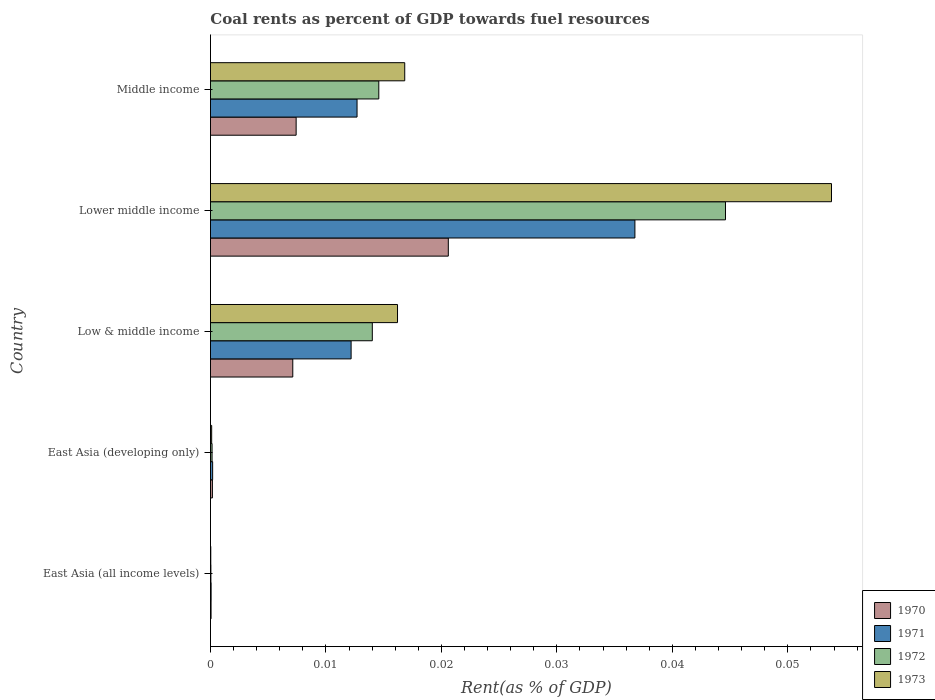How many different coloured bars are there?
Offer a terse response. 4. How many bars are there on the 3rd tick from the top?
Your answer should be compact. 4. How many bars are there on the 2nd tick from the bottom?
Give a very brief answer. 4. What is the label of the 2nd group of bars from the top?
Your answer should be very brief. Lower middle income. What is the coal rent in 1970 in Low & middle income?
Offer a very short reply. 0.01. Across all countries, what is the maximum coal rent in 1973?
Offer a terse response. 0.05. Across all countries, what is the minimum coal rent in 1973?
Make the answer very short. 2.64171247686014e-5. In which country was the coal rent in 1972 maximum?
Your answer should be very brief. Lower middle income. In which country was the coal rent in 1971 minimum?
Your answer should be very brief. East Asia (all income levels). What is the total coal rent in 1972 in the graph?
Offer a terse response. 0.07. What is the difference between the coal rent in 1971 in East Asia (all income levels) and that in Low & middle income?
Give a very brief answer. -0.01. What is the difference between the coal rent in 1971 in East Asia (developing only) and the coal rent in 1973 in Low & middle income?
Provide a short and direct response. -0.02. What is the average coal rent in 1971 per country?
Offer a very short reply. 0.01. What is the difference between the coal rent in 1971 and coal rent in 1972 in East Asia (developing only)?
Make the answer very short. 4.9569085611083014e-5. In how many countries, is the coal rent in 1971 greater than 0.05 %?
Provide a short and direct response. 0. What is the ratio of the coal rent in 1973 in East Asia (developing only) to that in Low & middle income?
Your answer should be very brief. 0.01. What is the difference between the highest and the second highest coal rent in 1971?
Make the answer very short. 0.02. What is the difference between the highest and the lowest coal rent in 1972?
Your answer should be very brief. 0.04. What does the 2nd bar from the top in Lower middle income represents?
Offer a very short reply. 1972. What does the 2nd bar from the bottom in Low & middle income represents?
Keep it short and to the point. 1971. How many bars are there?
Your answer should be compact. 20. What is the difference between two consecutive major ticks on the X-axis?
Keep it short and to the point. 0.01. Are the values on the major ticks of X-axis written in scientific E-notation?
Make the answer very short. No. Where does the legend appear in the graph?
Your answer should be compact. Bottom right. What is the title of the graph?
Make the answer very short. Coal rents as percent of GDP towards fuel resources. Does "1977" appear as one of the legend labels in the graph?
Provide a succinct answer. No. What is the label or title of the X-axis?
Offer a terse response. Rent(as % of GDP). What is the Rent(as % of GDP) of 1970 in East Asia (all income levels)?
Give a very brief answer. 5.1314079013758e-5. What is the Rent(as % of GDP) of 1971 in East Asia (all income levels)?
Give a very brief answer. 5.470114168356261e-5. What is the Rent(as % of GDP) in 1972 in East Asia (all income levels)?
Keep it short and to the point. 3.67730514806032e-5. What is the Rent(as % of GDP) in 1973 in East Asia (all income levels)?
Your answer should be compact. 2.64171247686014e-5. What is the Rent(as % of GDP) in 1970 in East Asia (developing only)?
Provide a short and direct response. 0. What is the Rent(as % of GDP) of 1971 in East Asia (developing only)?
Keep it short and to the point. 0. What is the Rent(as % of GDP) of 1972 in East Asia (developing only)?
Your answer should be compact. 0. What is the Rent(as % of GDP) in 1973 in East Asia (developing only)?
Offer a terse response. 0. What is the Rent(as % of GDP) of 1970 in Low & middle income?
Your answer should be compact. 0.01. What is the Rent(as % of GDP) of 1971 in Low & middle income?
Provide a short and direct response. 0.01. What is the Rent(as % of GDP) of 1972 in Low & middle income?
Provide a short and direct response. 0.01. What is the Rent(as % of GDP) in 1973 in Low & middle income?
Give a very brief answer. 0.02. What is the Rent(as % of GDP) in 1970 in Lower middle income?
Ensure brevity in your answer.  0.02. What is the Rent(as % of GDP) in 1971 in Lower middle income?
Ensure brevity in your answer.  0.04. What is the Rent(as % of GDP) in 1972 in Lower middle income?
Give a very brief answer. 0.04. What is the Rent(as % of GDP) of 1973 in Lower middle income?
Keep it short and to the point. 0.05. What is the Rent(as % of GDP) in 1970 in Middle income?
Make the answer very short. 0.01. What is the Rent(as % of GDP) of 1971 in Middle income?
Ensure brevity in your answer.  0.01. What is the Rent(as % of GDP) of 1972 in Middle income?
Your response must be concise. 0.01. What is the Rent(as % of GDP) in 1973 in Middle income?
Make the answer very short. 0.02. Across all countries, what is the maximum Rent(as % of GDP) in 1970?
Give a very brief answer. 0.02. Across all countries, what is the maximum Rent(as % of GDP) in 1971?
Provide a short and direct response. 0.04. Across all countries, what is the maximum Rent(as % of GDP) in 1972?
Give a very brief answer. 0.04. Across all countries, what is the maximum Rent(as % of GDP) in 1973?
Provide a succinct answer. 0.05. Across all countries, what is the minimum Rent(as % of GDP) of 1970?
Provide a short and direct response. 5.1314079013758e-5. Across all countries, what is the minimum Rent(as % of GDP) in 1971?
Provide a succinct answer. 5.470114168356261e-5. Across all countries, what is the minimum Rent(as % of GDP) in 1972?
Provide a succinct answer. 3.67730514806032e-5. Across all countries, what is the minimum Rent(as % of GDP) of 1973?
Provide a succinct answer. 2.64171247686014e-5. What is the total Rent(as % of GDP) of 1970 in the graph?
Your answer should be very brief. 0.04. What is the total Rent(as % of GDP) in 1971 in the graph?
Offer a very short reply. 0.06. What is the total Rent(as % of GDP) of 1972 in the graph?
Your response must be concise. 0.07. What is the total Rent(as % of GDP) in 1973 in the graph?
Your answer should be compact. 0.09. What is the difference between the Rent(as % of GDP) of 1970 in East Asia (all income levels) and that in East Asia (developing only)?
Ensure brevity in your answer.  -0. What is the difference between the Rent(as % of GDP) of 1971 in East Asia (all income levels) and that in East Asia (developing only)?
Your response must be concise. -0. What is the difference between the Rent(as % of GDP) of 1972 in East Asia (all income levels) and that in East Asia (developing only)?
Your answer should be very brief. -0. What is the difference between the Rent(as % of GDP) in 1973 in East Asia (all income levels) and that in East Asia (developing only)?
Your answer should be compact. -0. What is the difference between the Rent(as % of GDP) of 1970 in East Asia (all income levels) and that in Low & middle income?
Your answer should be compact. -0.01. What is the difference between the Rent(as % of GDP) of 1971 in East Asia (all income levels) and that in Low & middle income?
Provide a short and direct response. -0.01. What is the difference between the Rent(as % of GDP) of 1972 in East Asia (all income levels) and that in Low & middle income?
Make the answer very short. -0.01. What is the difference between the Rent(as % of GDP) in 1973 in East Asia (all income levels) and that in Low & middle income?
Your response must be concise. -0.02. What is the difference between the Rent(as % of GDP) of 1970 in East Asia (all income levels) and that in Lower middle income?
Make the answer very short. -0.02. What is the difference between the Rent(as % of GDP) of 1971 in East Asia (all income levels) and that in Lower middle income?
Your response must be concise. -0.04. What is the difference between the Rent(as % of GDP) in 1972 in East Asia (all income levels) and that in Lower middle income?
Give a very brief answer. -0.04. What is the difference between the Rent(as % of GDP) in 1973 in East Asia (all income levels) and that in Lower middle income?
Your answer should be compact. -0.05. What is the difference between the Rent(as % of GDP) in 1970 in East Asia (all income levels) and that in Middle income?
Your response must be concise. -0.01. What is the difference between the Rent(as % of GDP) of 1971 in East Asia (all income levels) and that in Middle income?
Your answer should be very brief. -0.01. What is the difference between the Rent(as % of GDP) in 1972 in East Asia (all income levels) and that in Middle income?
Make the answer very short. -0.01. What is the difference between the Rent(as % of GDP) of 1973 in East Asia (all income levels) and that in Middle income?
Offer a terse response. -0.02. What is the difference between the Rent(as % of GDP) in 1970 in East Asia (developing only) and that in Low & middle income?
Ensure brevity in your answer.  -0.01. What is the difference between the Rent(as % of GDP) of 1971 in East Asia (developing only) and that in Low & middle income?
Make the answer very short. -0.01. What is the difference between the Rent(as % of GDP) of 1972 in East Asia (developing only) and that in Low & middle income?
Ensure brevity in your answer.  -0.01. What is the difference between the Rent(as % of GDP) in 1973 in East Asia (developing only) and that in Low & middle income?
Your response must be concise. -0.02. What is the difference between the Rent(as % of GDP) in 1970 in East Asia (developing only) and that in Lower middle income?
Your answer should be compact. -0.02. What is the difference between the Rent(as % of GDP) in 1971 in East Asia (developing only) and that in Lower middle income?
Offer a terse response. -0.04. What is the difference between the Rent(as % of GDP) of 1972 in East Asia (developing only) and that in Lower middle income?
Your response must be concise. -0.04. What is the difference between the Rent(as % of GDP) in 1973 in East Asia (developing only) and that in Lower middle income?
Your response must be concise. -0.05. What is the difference between the Rent(as % of GDP) in 1970 in East Asia (developing only) and that in Middle income?
Give a very brief answer. -0.01. What is the difference between the Rent(as % of GDP) in 1971 in East Asia (developing only) and that in Middle income?
Your answer should be compact. -0.01. What is the difference between the Rent(as % of GDP) in 1972 in East Asia (developing only) and that in Middle income?
Give a very brief answer. -0.01. What is the difference between the Rent(as % of GDP) of 1973 in East Asia (developing only) and that in Middle income?
Offer a terse response. -0.02. What is the difference between the Rent(as % of GDP) in 1970 in Low & middle income and that in Lower middle income?
Make the answer very short. -0.01. What is the difference between the Rent(as % of GDP) of 1971 in Low & middle income and that in Lower middle income?
Your response must be concise. -0.02. What is the difference between the Rent(as % of GDP) of 1972 in Low & middle income and that in Lower middle income?
Make the answer very short. -0.03. What is the difference between the Rent(as % of GDP) in 1973 in Low & middle income and that in Lower middle income?
Offer a terse response. -0.04. What is the difference between the Rent(as % of GDP) of 1970 in Low & middle income and that in Middle income?
Provide a short and direct response. -0. What is the difference between the Rent(as % of GDP) in 1971 in Low & middle income and that in Middle income?
Your answer should be very brief. -0. What is the difference between the Rent(as % of GDP) of 1972 in Low & middle income and that in Middle income?
Your answer should be very brief. -0. What is the difference between the Rent(as % of GDP) in 1973 in Low & middle income and that in Middle income?
Keep it short and to the point. -0. What is the difference between the Rent(as % of GDP) in 1970 in Lower middle income and that in Middle income?
Offer a very short reply. 0.01. What is the difference between the Rent(as % of GDP) in 1971 in Lower middle income and that in Middle income?
Make the answer very short. 0.02. What is the difference between the Rent(as % of GDP) of 1973 in Lower middle income and that in Middle income?
Your answer should be very brief. 0.04. What is the difference between the Rent(as % of GDP) of 1970 in East Asia (all income levels) and the Rent(as % of GDP) of 1971 in East Asia (developing only)?
Offer a terse response. -0. What is the difference between the Rent(as % of GDP) in 1970 in East Asia (all income levels) and the Rent(as % of GDP) in 1972 in East Asia (developing only)?
Your answer should be very brief. -0. What is the difference between the Rent(as % of GDP) in 1970 in East Asia (all income levels) and the Rent(as % of GDP) in 1973 in East Asia (developing only)?
Your answer should be compact. -0. What is the difference between the Rent(as % of GDP) of 1971 in East Asia (all income levels) and the Rent(as % of GDP) of 1972 in East Asia (developing only)?
Your answer should be compact. -0. What is the difference between the Rent(as % of GDP) in 1972 in East Asia (all income levels) and the Rent(as % of GDP) in 1973 in East Asia (developing only)?
Keep it short and to the point. -0. What is the difference between the Rent(as % of GDP) of 1970 in East Asia (all income levels) and the Rent(as % of GDP) of 1971 in Low & middle income?
Your response must be concise. -0.01. What is the difference between the Rent(as % of GDP) of 1970 in East Asia (all income levels) and the Rent(as % of GDP) of 1972 in Low & middle income?
Give a very brief answer. -0.01. What is the difference between the Rent(as % of GDP) of 1970 in East Asia (all income levels) and the Rent(as % of GDP) of 1973 in Low & middle income?
Give a very brief answer. -0.02. What is the difference between the Rent(as % of GDP) in 1971 in East Asia (all income levels) and the Rent(as % of GDP) in 1972 in Low & middle income?
Offer a very short reply. -0.01. What is the difference between the Rent(as % of GDP) of 1971 in East Asia (all income levels) and the Rent(as % of GDP) of 1973 in Low & middle income?
Ensure brevity in your answer.  -0.02. What is the difference between the Rent(as % of GDP) in 1972 in East Asia (all income levels) and the Rent(as % of GDP) in 1973 in Low & middle income?
Make the answer very short. -0.02. What is the difference between the Rent(as % of GDP) of 1970 in East Asia (all income levels) and the Rent(as % of GDP) of 1971 in Lower middle income?
Your response must be concise. -0.04. What is the difference between the Rent(as % of GDP) of 1970 in East Asia (all income levels) and the Rent(as % of GDP) of 1972 in Lower middle income?
Provide a short and direct response. -0.04. What is the difference between the Rent(as % of GDP) in 1970 in East Asia (all income levels) and the Rent(as % of GDP) in 1973 in Lower middle income?
Your answer should be compact. -0.05. What is the difference between the Rent(as % of GDP) of 1971 in East Asia (all income levels) and the Rent(as % of GDP) of 1972 in Lower middle income?
Your response must be concise. -0.04. What is the difference between the Rent(as % of GDP) in 1971 in East Asia (all income levels) and the Rent(as % of GDP) in 1973 in Lower middle income?
Make the answer very short. -0.05. What is the difference between the Rent(as % of GDP) in 1972 in East Asia (all income levels) and the Rent(as % of GDP) in 1973 in Lower middle income?
Offer a terse response. -0.05. What is the difference between the Rent(as % of GDP) in 1970 in East Asia (all income levels) and the Rent(as % of GDP) in 1971 in Middle income?
Offer a very short reply. -0.01. What is the difference between the Rent(as % of GDP) of 1970 in East Asia (all income levels) and the Rent(as % of GDP) of 1972 in Middle income?
Offer a terse response. -0.01. What is the difference between the Rent(as % of GDP) in 1970 in East Asia (all income levels) and the Rent(as % of GDP) in 1973 in Middle income?
Ensure brevity in your answer.  -0.02. What is the difference between the Rent(as % of GDP) in 1971 in East Asia (all income levels) and the Rent(as % of GDP) in 1972 in Middle income?
Offer a terse response. -0.01. What is the difference between the Rent(as % of GDP) in 1971 in East Asia (all income levels) and the Rent(as % of GDP) in 1973 in Middle income?
Provide a succinct answer. -0.02. What is the difference between the Rent(as % of GDP) in 1972 in East Asia (all income levels) and the Rent(as % of GDP) in 1973 in Middle income?
Your answer should be compact. -0.02. What is the difference between the Rent(as % of GDP) in 1970 in East Asia (developing only) and the Rent(as % of GDP) in 1971 in Low & middle income?
Ensure brevity in your answer.  -0.01. What is the difference between the Rent(as % of GDP) in 1970 in East Asia (developing only) and the Rent(as % of GDP) in 1972 in Low & middle income?
Offer a very short reply. -0.01. What is the difference between the Rent(as % of GDP) in 1970 in East Asia (developing only) and the Rent(as % of GDP) in 1973 in Low & middle income?
Your answer should be very brief. -0.02. What is the difference between the Rent(as % of GDP) in 1971 in East Asia (developing only) and the Rent(as % of GDP) in 1972 in Low & middle income?
Provide a succinct answer. -0.01. What is the difference between the Rent(as % of GDP) of 1971 in East Asia (developing only) and the Rent(as % of GDP) of 1973 in Low & middle income?
Offer a terse response. -0.02. What is the difference between the Rent(as % of GDP) of 1972 in East Asia (developing only) and the Rent(as % of GDP) of 1973 in Low & middle income?
Give a very brief answer. -0.02. What is the difference between the Rent(as % of GDP) in 1970 in East Asia (developing only) and the Rent(as % of GDP) in 1971 in Lower middle income?
Make the answer very short. -0.04. What is the difference between the Rent(as % of GDP) in 1970 in East Asia (developing only) and the Rent(as % of GDP) in 1972 in Lower middle income?
Ensure brevity in your answer.  -0.04. What is the difference between the Rent(as % of GDP) of 1970 in East Asia (developing only) and the Rent(as % of GDP) of 1973 in Lower middle income?
Offer a terse response. -0.05. What is the difference between the Rent(as % of GDP) of 1971 in East Asia (developing only) and the Rent(as % of GDP) of 1972 in Lower middle income?
Keep it short and to the point. -0.04. What is the difference between the Rent(as % of GDP) in 1971 in East Asia (developing only) and the Rent(as % of GDP) in 1973 in Lower middle income?
Offer a very short reply. -0.05. What is the difference between the Rent(as % of GDP) in 1972 in East Asia (developing only) and the Rent(as % of GDP) in 1973 in Lower middle income?
Give a very brief answer. -0.05. What is the difference between the Rent(as % of GDP) of 1970 in East Asia (developing only) and the Rent(as % of GDP) of 1971 in Middle income?
Your answer should be very brief. -0.01. What is the difference between the Rent(as % of GDP) of 1970 in East Asia (developing only) and the Rent(as % of GDP) of 1972 in Middle income?
Provide a succinct answer. -0.01. What is the difference between the Rent(as % of GDP) of 1970 in East Asia (developing only) and the Rent(as % of GDP) of 1973 in Middle income?
Provide a short and direct response. -0.02. What is the difference between the Rent(as % of GDP) in 1971 in East Asia (developing only) and the Rent(as % of GDP) in 1972 in Middle income?
Your answer should be very brief. -0.01. What is the difference between the Rent(as % of GDP) in 1971 in East Asia (developing only) and the Rent(as % of GDP) in 1973 in Middle income?
Offer a very short reply. -0.02. What is the difference between the Rent(as % of GDP) in 1972 in East Asia (developing only) and the Rent(as % of GDP) in 1973 in Middle income?
Your answer should be very brief. -0.02. What is the difference between the Rent(as % of GDP) of 1970 in Low & middle income and the Rent(as % of GDP) of 1971 in Lower middle income?
Offer a terse response. -0.03. What is the difference between the Rent(as % of GDP) of 1970 in Low & middle income and the Rent(as % of GDP) of 1972 in Lower middle income?
Provide a succinct answer. -0.04. What is the difference between the Rent(as % of GDP) of 1970 in Low & middle income and the Rent(as % of GDP) of 1973 in Lower middle income?
Offer a terse response. -0.05. What is the difference between the Rent(as % of GDP) in 1971 in Low & middle income and the Rent(as % of GDP) in 1972 in Lower middle income?
Your answer should be compact. -0.03. What is the difference between the Rent(as % of GDP) in 1971 in Low & middle income and the Rent(as % of GDP) in 1973 in Lower middle income?
Keep it short and to the point. -0.04. What is the difference between the Rent(as % of GDP) of 1972 in Low & middle income and the Rent(as % of GDP) of 1973 in Lower middle income?
Your answer should be compact. -0.04. What is the difference between the Rent(as % of GDP) of 1970 in Low & middle income and the Rent(as % of GDP) of 1971 in Middle income?
Give a very brief answer. -0.01. What is the difference between the Rent(as % of GDP) in 1970 in Low & middle income and the Rent(as % of GDP) in 1972 in Middle income?
Your answer should be very brief. -0.01. What is the difference between the Rent(as % of GDP) in 1970 in Low & middle income and the Rent(as % of GDP) in 1973 in Middle income?
Ensure brevity in your answer.  -0.01. What is the difference between the Rent(as % of GDP) in 1971 in Low & middle income and the Rent(as % of GDP) in 1972 in Middle income?
Give a very brief answer. -0. What is the difference between the Rent(as % of GDP) in 1971 in Low & middle income and the Rent(as % of GDP) in 1973 in Middle income?
Your answer should be very brief. -0. What is the difference between the Rent(as % of GDP) in 1972 in Low & middle income and the Rent(as % of GDP) in 1973 in Middle income?
Give a very brief answer. -0. What is the difference between the Rent(as % of GDP) in 1970 in Lower middle income and the Rent(as % of GDP) in 1971 in Middle income?
Your answer should be compact. 0.01. What is the difference between the Rent(as % of GDP) in 1970 in Lower middle income and the Rent(as % of GDP) in 1972 in Middle income?
Provide a succinct answer. 0.01. What is the difference between the Rent(as % of GDP) of 1970 in Lower middle income and the Rent(as % of GDP) of 1973 in Middle income?
Offer a very short reply. 0. What is the difference between the Rent(as % of GDP) in 1971 in Lower middle income and the Rent(as % of GDP) in 1972 in Middle income?
Provide a short and direct response. 0.02. What is the difference between the Rent(as % of GDP) in 1971 in Lower middle income and the Rent(as % of GDP) in 1973 in Middle income?
Give a very brief answer. 0.02. What is the difference between the Rent(as % of GDP) in 1972 in Lower middle income and the Rent(as % of GDP) in 1973 in Middle income?
Your answer should be very brief. 0.03. What is the average Rent(as % of GDP) of 1970 per country?
Your answer should be very brief. 0.01. What is the average Rent(as % of GDP) of 1971 per country?
Your answer should be compact. 0.01. What is the average Rent(as % of GDP) of 1972 per country?
Make the answer very short. 0.01. What is the average Rent(as % of GDP) of 1973 per country?
Your answer should be very brief. 0.02. What is the difference between the Rent(as % of GDP) of 1970 and Rent(as % of GDP) of 1971 in East Asia (all income levels)?
Provide a short and direct response. -0. What is the difference between the Rent(as % of GDP) of 1970 and Rent(as % of GDP) of 1972 in East Asia (all income levels)?
Ensure brevity in your answer.  0. What is the difference between the Rent(as % of GDP) of 1970 and Rent(as % of GDP) of 1973 in East Asia (all income levels)?
Your answer should be compact. 0. What is the difference between the Rent(as % of GDP) in 1971 and Rent(as % of GDP) in 1972 in East Asia (all income levels)?
Offer a terse response. 0. What is the difference between the Rent(as % of GDP) in 1971 and Rent(as % of GDP) in 1973 in East Asia (all income levels)?
Provide a succinct answer. 0. What is the difference between the Rent(as % of GDP) in 1972 and Rent(as % of GDP) in 1973 in East Asia (all income levels)?
Provide a short and direct response. 0. What is the difference between the Rent(as % of GDP) in 1971 and Rent(as % of GDP) in 1972 in East Asia (developing only)?
Offer a very short reply. 0. What is the difference between the Rent(as % of GDP) in 1972 and Rent(as % of GDP) in 1973 in East Asia (developing only)?
Give a very brief answer. 0. What is the difference between the Rent(as % of GDP) of 1970 and Rent(as % of GDP) of 1971 in Low & middle income?
Provide a succinct answer. -0.01. What is the difference between the Rent(as % of GDP) in 1970 and Rent(as % of GDP) in 1972 in Low & middle income?
Offer a terse response. -0.01. What is the difference between the Rent(as % of GDP) of 1970 and Rent(as % of GDP) of 1973 in Low & middle income?
Provide a succinct answer. -0.01. What is the difference between the Rent(as % of GDP) of 1971 and Rent(as % of GDP) of 1972 in Low & middle income?
Provide a succinct answer. -0. What is the difference between the Rent(as % of GDP) in 1971 and Rent(as % of GDP) in 1973 in Low & middle income?
Ensure brevity in your answer.  -0. What is the difference between the Rent(as % of GDP) of 1972 and Rent(as % of GDP) of 1973 in Low & middle income?
Keep it short and to the point. -0. What is the difference between the Rent(as % of GDP) in 1970 and Rent(as % of GDP) in 1971 in Lower middle income?
Your answer should be very brief. -0.02. What is the difference between the Rent(as % of GDP) of 1970 and Rent(as % of GDP) of 1972 in Lower middle income?
Your answer should be compact. -0.02. What is the difference between the Rent(as % of GDP) of 1970 and Rent(as % of GDP) of 1973 in Lower middle income?
Give a very brief answer. -0.03. What is the difference between the Rent(as % of GDP) in 1971 and Rent(as % of GDP) in 1972 in Lower middle income?
Your response must be concise. -0.01. What is the difference between the Rent(as % of GDP) in 1971 and Rent(as % of GDP) in 1973 in Lower middle income?
Give a very brief answer. -0.02. What is the difference between the Rent(as % of GDP) in 1972 and Rent(as % of GDP) in 1973 in Lower middle income?
Ensure brevity in your answer.  -0.01. What is the difference between the Rent(as % of GDP) in 1970 and Rent(as % of GDP) in 1971 in Middle income?
Your response must be concise. -0.01. What is the difference between the Rent(as % of GDP) in 1970 and Rent(as % of GDP) in 1972 in Middle income?
Make the answer very short. -0.01. What is the difference between the Rent(as % of GDP) of 1970 and Rent(as % of GDP) of 1973 in Middle income?
Provide a succinct answer. -0.01. What is the difference between the Rent(as % of GDP) in 1971 and Rent(as % of GDP) in 1972 in Middle income?
Provide a short and direct response. -0. What is the difference between the Rent(as % of GDP) in 1971 and Rent(as % of GDP) in 1973 in Middle income?
Provide a succinct answer. -0. What is the difference between the Rent(as % of GDP) of 1972 and Rent(as % of GDP) of 1973 in Middle income?
Make the answer very short. -0. What is the ratio of the Rent(as % of GDP) in 1970 in East Asia (all income levels) to that in East Asia (developing only)?
Your answer should be compact. 0.31. What is the ratio of the Rent(as % of GDP) of 1971 in East Asia (all income levels) to that in East Asia (developing only)?
Your answer should be compact. 0.29. What is the ratio of the Rent(as % of GDP) in 1972 in East Asia (all income levels) to that in East Asia (developing only)?
Offer a terse response. 0.27. What is the ratio of the Rent(as % of GDP) in 1973 in East Asia (all income levels) to that in East Asia (developing only)?
Provide a succinct answer. 0.26. What is the ratio of the Rent(as % of GDP) in 1970 in East Asia (all income levels) to that in Low & middle income?
Provide a succinct answer. 0.01. What is the ratio of the Rent(as % of GDP) of 1971 in East Asia (all income levels) to that in Low & middle income?
Provide a succinct answer. 0. What is the ratio of the Rent(as % of GDP) of 1972 in East Asia (all income levels) to that in Low & middle income?
Offer a very short reply. 0. What is the ratio of the Rent(as % of GDP) in 1973 in East Asia (all income levels) to that in Low & middle income?
Make the answer very short. 0. What is the ratio of the Rent(as % of GDP) in 1970 in East Asia (all income levels) to that in Lower middle income?
Your response must be concise. 0. What is the ratio of the Rent(as % of GDP) of 1971 in East Asia (all income levels) to that in Lower middle income?
Keep it short and to the point. 0. What is the ratio of the Rent(as % of GDP) of 1972 in East Asia (all income levels) to that in Lower middle income?
Give a very brief answer. 0. What is the ratio of the Rent(as % of GDP) of 1970 in East Asia (all income levels) to that in Middle income?
Offer a terse response. 0.01. What is the ratio of the Rent(as % of GDP) in 1971 in East Asia (all income levels) to that in Middle income?
Ensure brevity in your answer.  0. What is the ratio of the Rent(as % of GDP) in 1972 in East Asia (all income levels) to that in Middle income?
Provide a short and direct response. 0. What is the ratio of the Rent(as % of GDP) of 1973 in East Asia (all income levels) to that in Middle income?
Your answer should be very brief. 0. What is the ratio of the Rent(as % of GDP) in 1970 in East Asia (developing only) to that in Low & middle income?
Ensure brevity in your answer.  0.02. What is the ratio of the Rent(as % of GDP) of 1971 in East Asia (developing only) to that in Low & middle income?
Your answer should be very brief. 0.02. What is the ratio of the Rent(as % of GDP) of 1972 in East Asia (developing only) to that in Low & middle income?
Your response must be concise. 0.01. What is the ratio of the Rent(as % of GDP) in 1973 in East Asia (developing only) to that in Low & middle income?
Offer a very short reply. 0.01. What is the ratio of the Rent(as % of GDP) in 1970 in East Asia (developing only) to that in Lower middle income?
Offer a terse response. 0.01. What is the ratio of the Rent(as % of GDP) in 1971 in East Asia (developing only) to that in Lower middle income?
Your answer should be very brief. 0.01. What is the ratio of the Rent(as % of GDP) of 1972 in East Asia (developing only) to that in Lower middle income?
Keep it short and to the point. 0. What is the ratio of the Rent(as % of GDP) in 1973 in East Asia (developing only) to that in Lower middle income?
Your answer should be very brief. 0. What is the ratio of the Rent(as % of GDP) in 1970 in East Asia (developing only) to that in Middle income?
Provide a succinct answer. 0.02. What is the ratio of the Rent(as % of GDP) of 1971 in East Asia (developing only) to that in Middle income?
Ensure brevity in your answer.  0.01. What is the ratio of the Rent(as % of GDP) of 1972 in East Asia (developing only) to that in Middle income?
Offer a terse response. 0.01. What is the ratio of the Rent(as % of GDP) in 1973 in East Asia (developing only) to that in Middle income?
Your answer should be very brief. 0.01. What is the ratio of the Rent(as % of GDP) of 1970 in Low & middle income to that in Lower middle income?
Provide a succinct answer. 0.35. What is the ratio of the Rent(as % of GDP) of 1971 in Low & middle income to that in Lower middle income?
Give a very brief answer. 0.33. What is the ratio of the Rent(as % of GDP) in 1972 in Low & middle income to that in Lower middle income?
Provide a short and direct response. 0.31. What is the ratio of the Rent(as % of GDP) in 1973 in Low & middle income to that in Lower middle income?
Your answer should be compact. 0.3. What is the ratio of the Rent(as % of GDP) in 1970 in Low & middle income to that in Middle income?
Provide a succinct answer. 0.96. What is the ratio of the Rent(as % of GDP) of 1971 in Low & middle income to that in Middle income?
Provide a succinct answer. 0.96. What is the ratio of the Rent(as % of GDP) of 1972 in Low & middle income to that in Middle income?
Provide a short and direct response. 0.96. What is the ratio of the Rent(as % of GDP) of 1973 in Low & middle income to that in Middle income?
Keep it short and to the point. 0.96. What is the ratio of the Rent(as % of GDP) of 1970 in Lower middle income to that in Middle income?
Your response must be concise. 2.78. What is the ratio of the Rent(as % of GDP) in 1971 in Lower middle income to that in Middle income?
Your answer should be very brief. 2.9. What is the ratio of the Rent(as % of GDP) of 1972 in Lower middle income to that in Middle income?
Ensure brevity in your answer.  3.06. What is the ratio of the Rent(as % of GDP) of 1973 in Lower middle income to that in Middle income?
Provide a short and direct response. 3.2. What is the difference between the highest and the second highest Rent(as % of GDP) of 1970?
Your response must be concise. 0.01. What is the difference between the highest and the second highest Rent(as % of GDP) of 1971?
Ensure brevity in your answer.  0.02. What is the difference between the highest and the second highest Rent(as % of GDP) in 1973?
Provide a succinct answer. 0.04. What is the difference between the highest and the lowest Rent(as % of GDP) of 1970?
Ensure brevity in your answer.  0.02. What is the difference between the highest and the lowest Rent(as % of GDP) in 1971?
Keep it short and to the point. 0.04. What is the difference between the highest and the lowest Rent(as % of GDP) in 1972?
Ensure brevity in your answer.  0.04. What is the difference between the highest and the lowest Rent(as % of GDP) of 1973?
Provide a succinct answer. 0.05. 